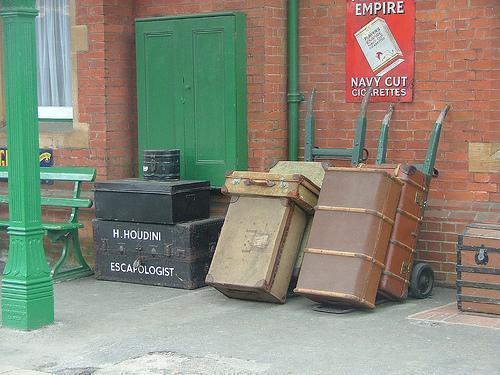How many signs do you see?
Give a very brief answer. 1. 